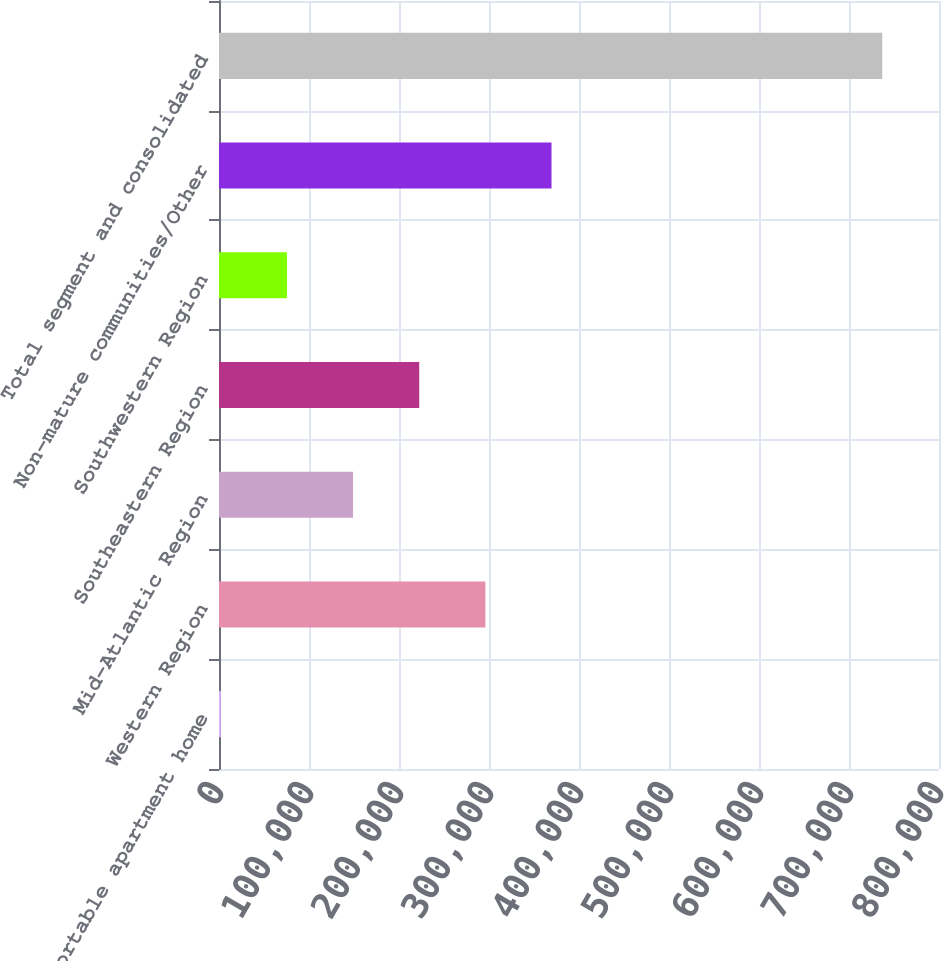<chart> <loc_0><loc_0><loc_500><loc_500><bar_chart><fcel>Reportable apartment home<fcel>Western Region<fcel>Mid-Atlantic Region<fcel>Southeastern Region<fcel>Southwestern Region<fcel>Non-mature communities/Other<fcel>Total segment and consolidated<nl><fcel>2006<fcel>295969<fcel>148988<fcel>222478<fcel>75496.8<fcel>369460<fcel>736914<nl></chart> 